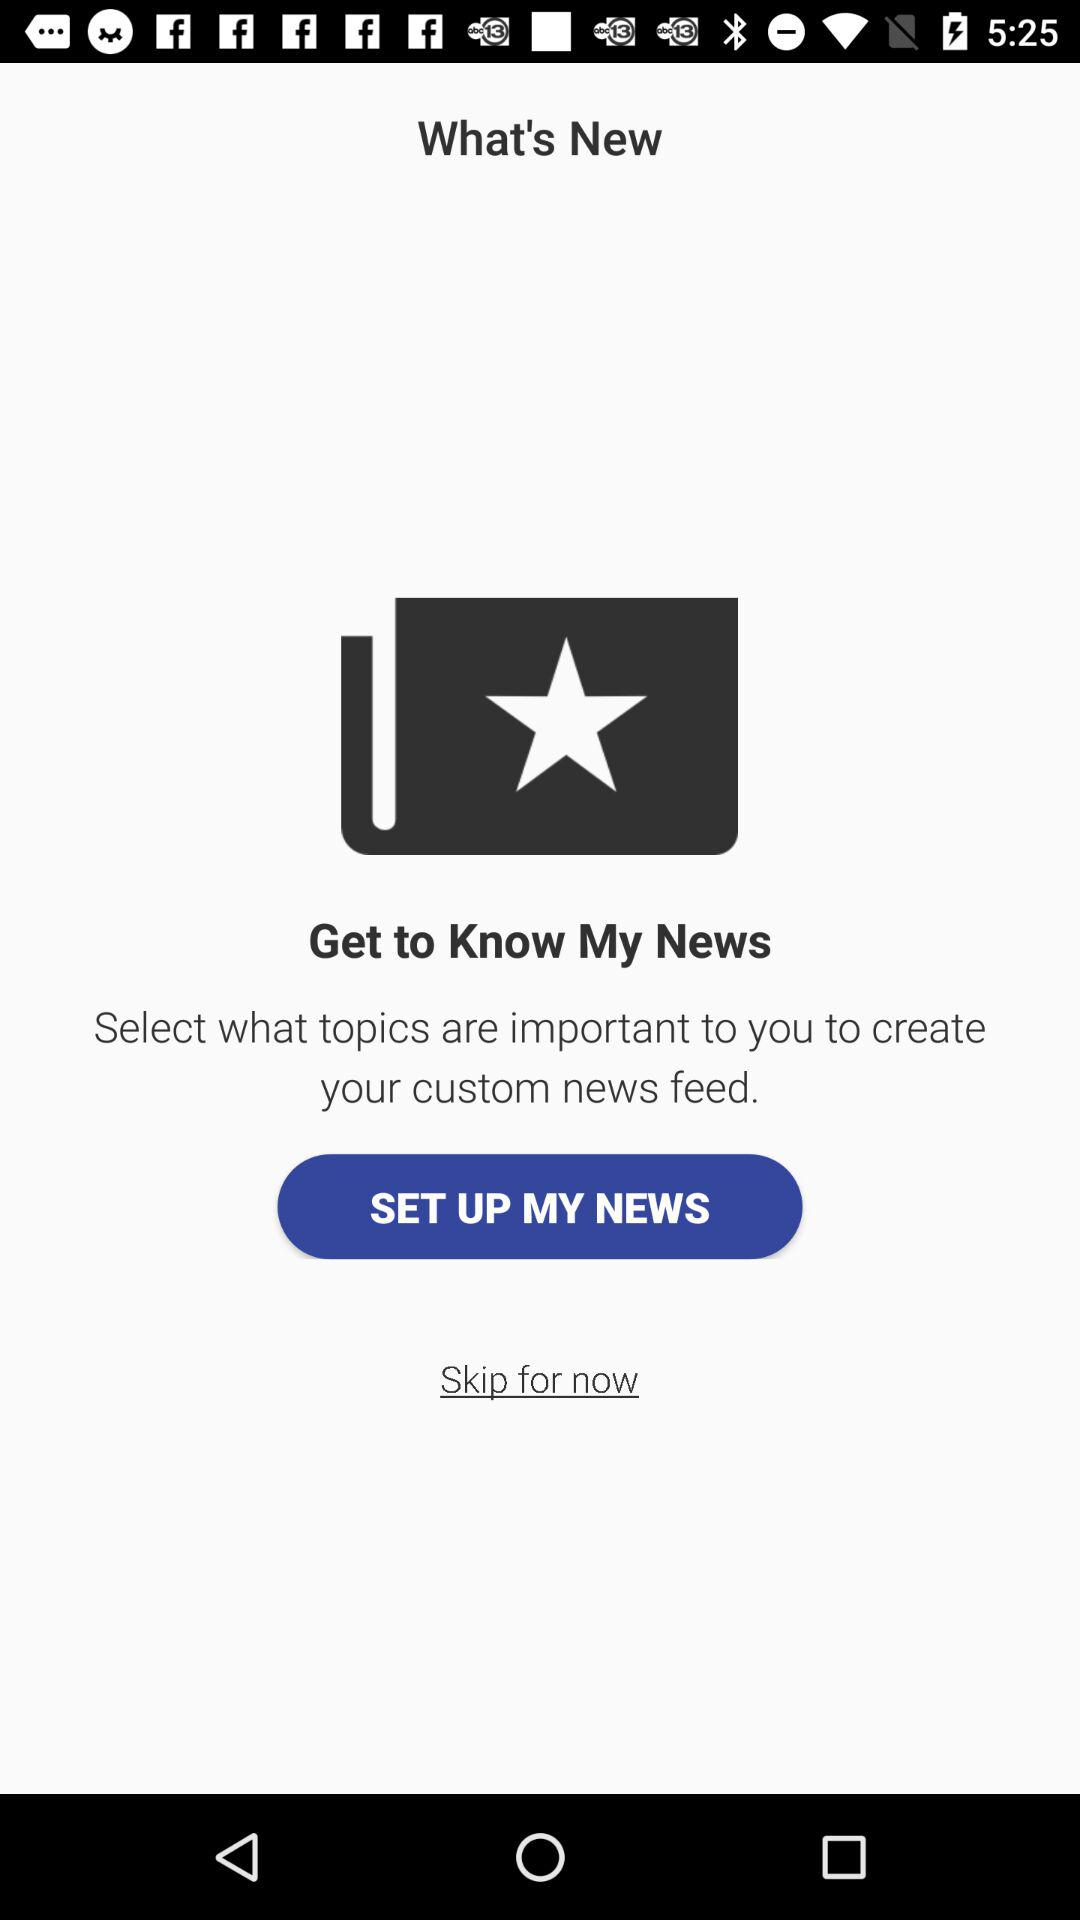What is the name of the application? The name of the application is "My News". 